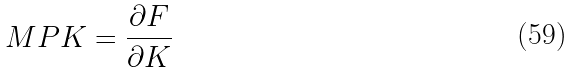<formula> <loc_0><loc_0><loc_500><loc_500>M P K = \frac { \partial F } { \partial K }</formula> 